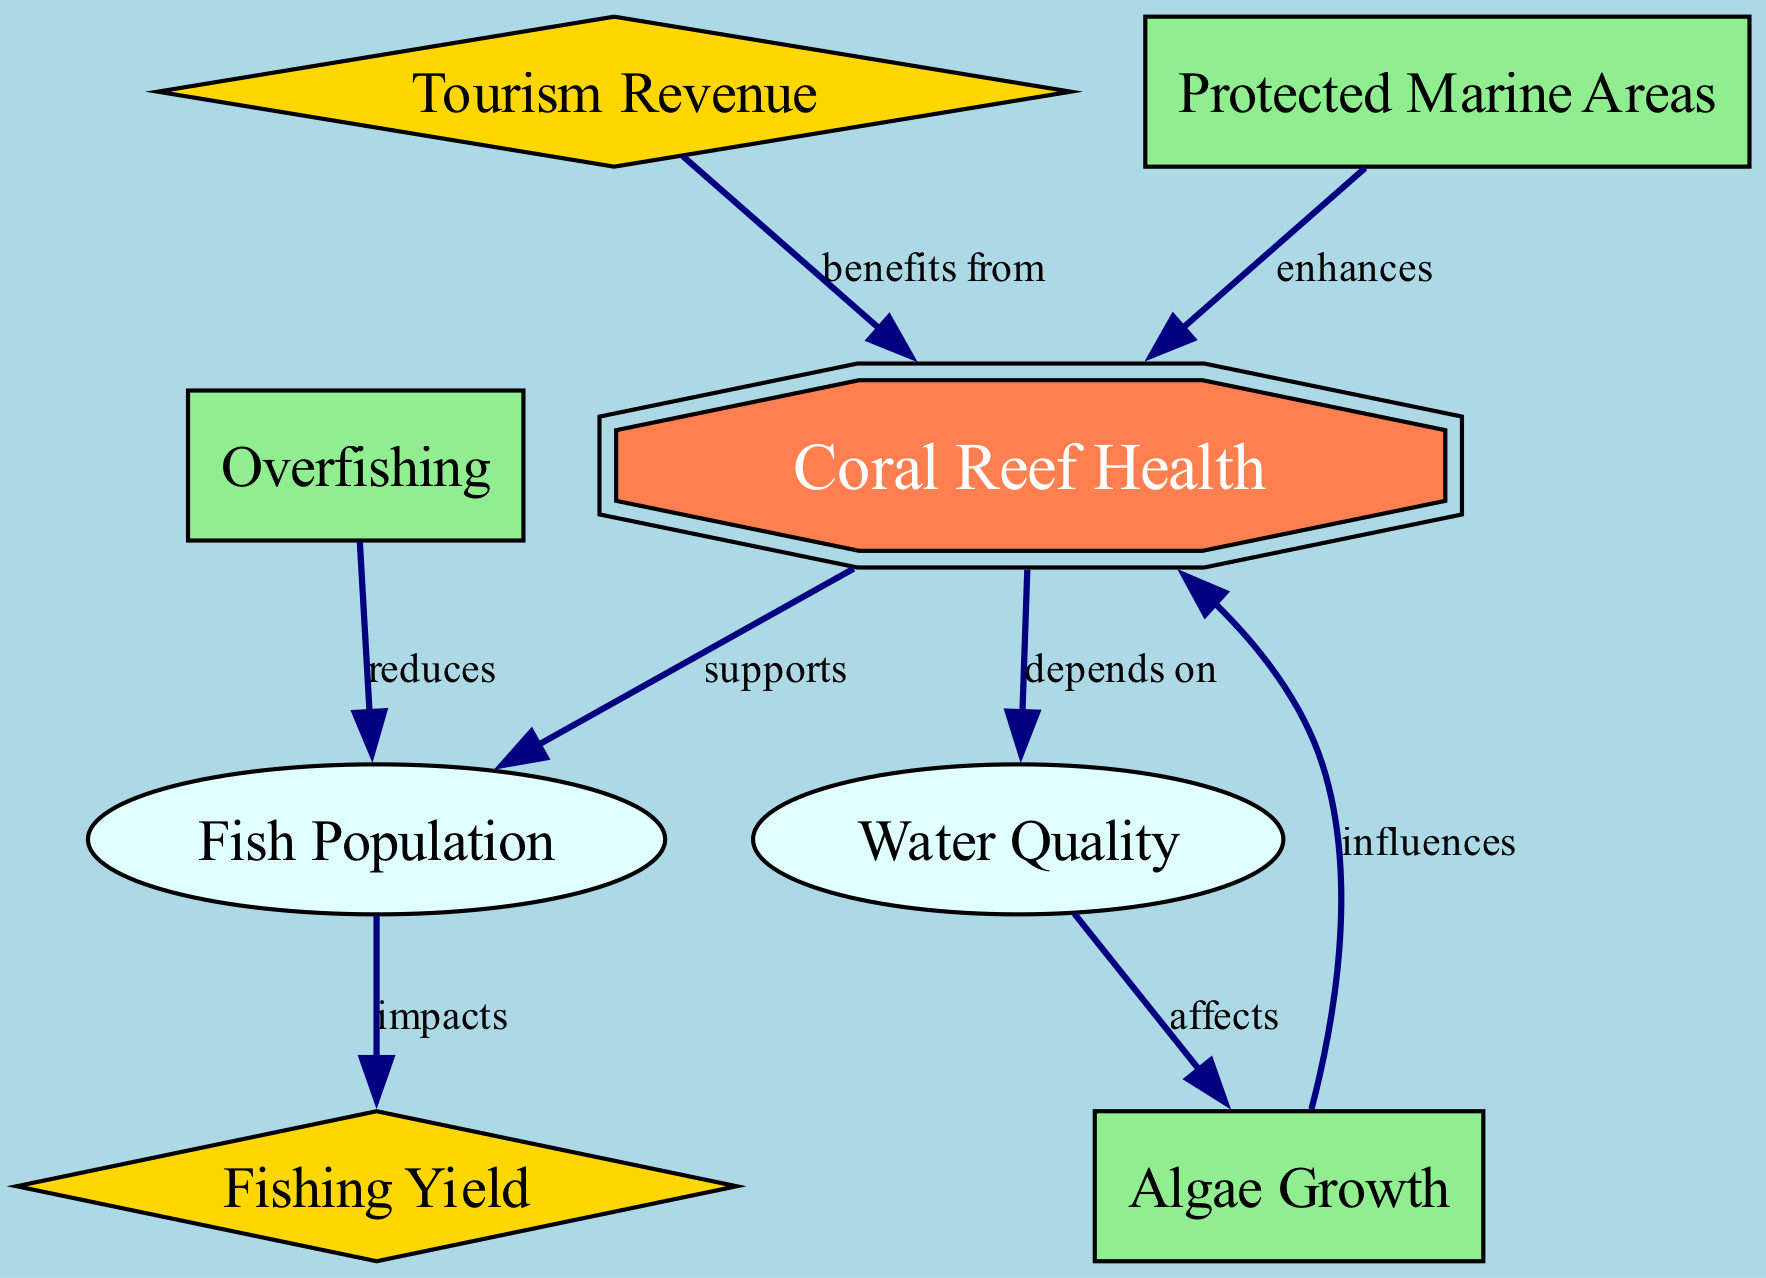What is the main factor that supports fish population? According to the diagram, coral reef health is indicated to support fish population directly.
Answer: Coral Reef Health How many nodes are present in the diagram? By counting the individual elements labeled in the diagram, we find a total of eight nodes listed.
Answer: Eight What impacts fishing yield? The diagram shows that fish population impacts fishing yield directly in the connections illustrated.
Answer: Fish Population What do protected areas enhance? The diagram clearly states that protected areas enhance coral reef health, as shown in the relationship between these two entities.
Answer: Coral Reef Health If water quality is affected, what does this lead to in terms of algae growth? The diagram indicates that water quality affects algae growth, as a direct relationship is established between the two nodes.
Answer: Affects What is one of the benefits of tourism concerning coral reefs? The diagram states that tourism benefits from coral reef health, signifying a positive association between these two aspects.
Answer: Coral Reef Health How does overfishing affect fish population? The connection in the diagram explicitly states that overfishing reduces fish population, establishing a negative impact.
Answer: Reduces What influences coral reef health? According to the diagram, algae growth influences coral reef health, thereby indicating a dependency or effect on the overall health of the reef system.
Answer: Algae Growth What is the relationship between water quality and algae growth? The diagram specifies that water quality affects algae growth, highlighting a direct relationship where water quality can influence the extent of algae presence.
Answer: Affects 